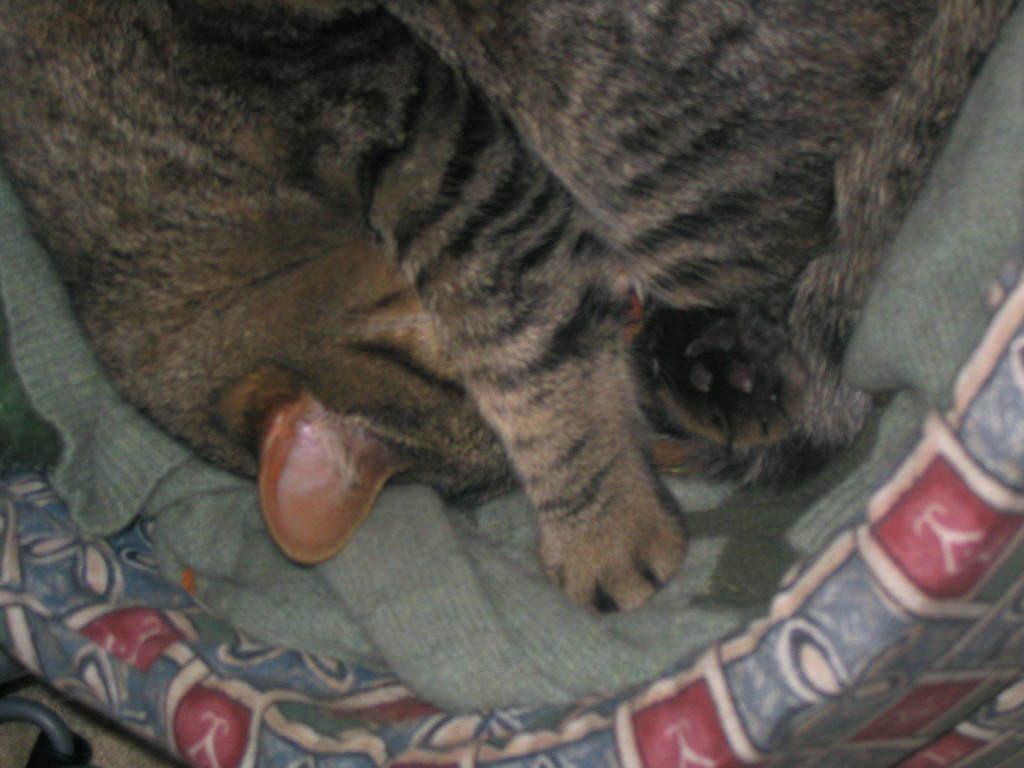Could you give a brief overview of what you see in this image? In this image we can see an animal in a blanket. The blanket is placed on the object which looks like a bed. 